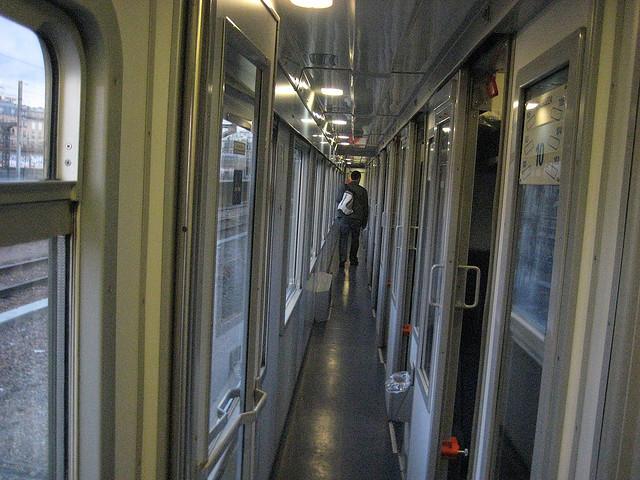Where is this hallway?
Quick response, please. Train. How many people are in this scene?
Be succinct. 1. Could two people walk side-by-side down this hallway?
Keep it brief. No. 